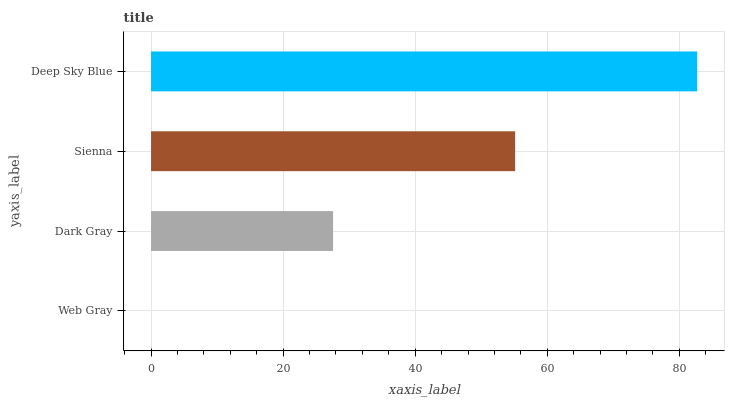Is Web Gray the minimum?
Answer yes or no. Yes. Is Deep Sky Blue the maximum?
Answer yes or no. Yes. Is Dark Gray the minimum?
Answer yes or no. No. Is Dark Gray the maximum?
Answer yes or no. No. Is Dark Gray greater than Web Gray?
Answer yes or no. Yes. Is Web Gray less than Dark Gray?
Answer yes or no. Yes. Is Web Gray greater than Dark Gray?
Answer yes or no. No. Is Dark Gray less than Web Gray?
Answer yes or no. No. Is Sienna the high median?
Answer yes or no. Yes. Is Dark Gray the low median?
Answer yes or no. Yes. Is Deep Sky Blue the high median?
Answer yes or no. No. Is Web Gray the low median?
Answer yes or no. No. 